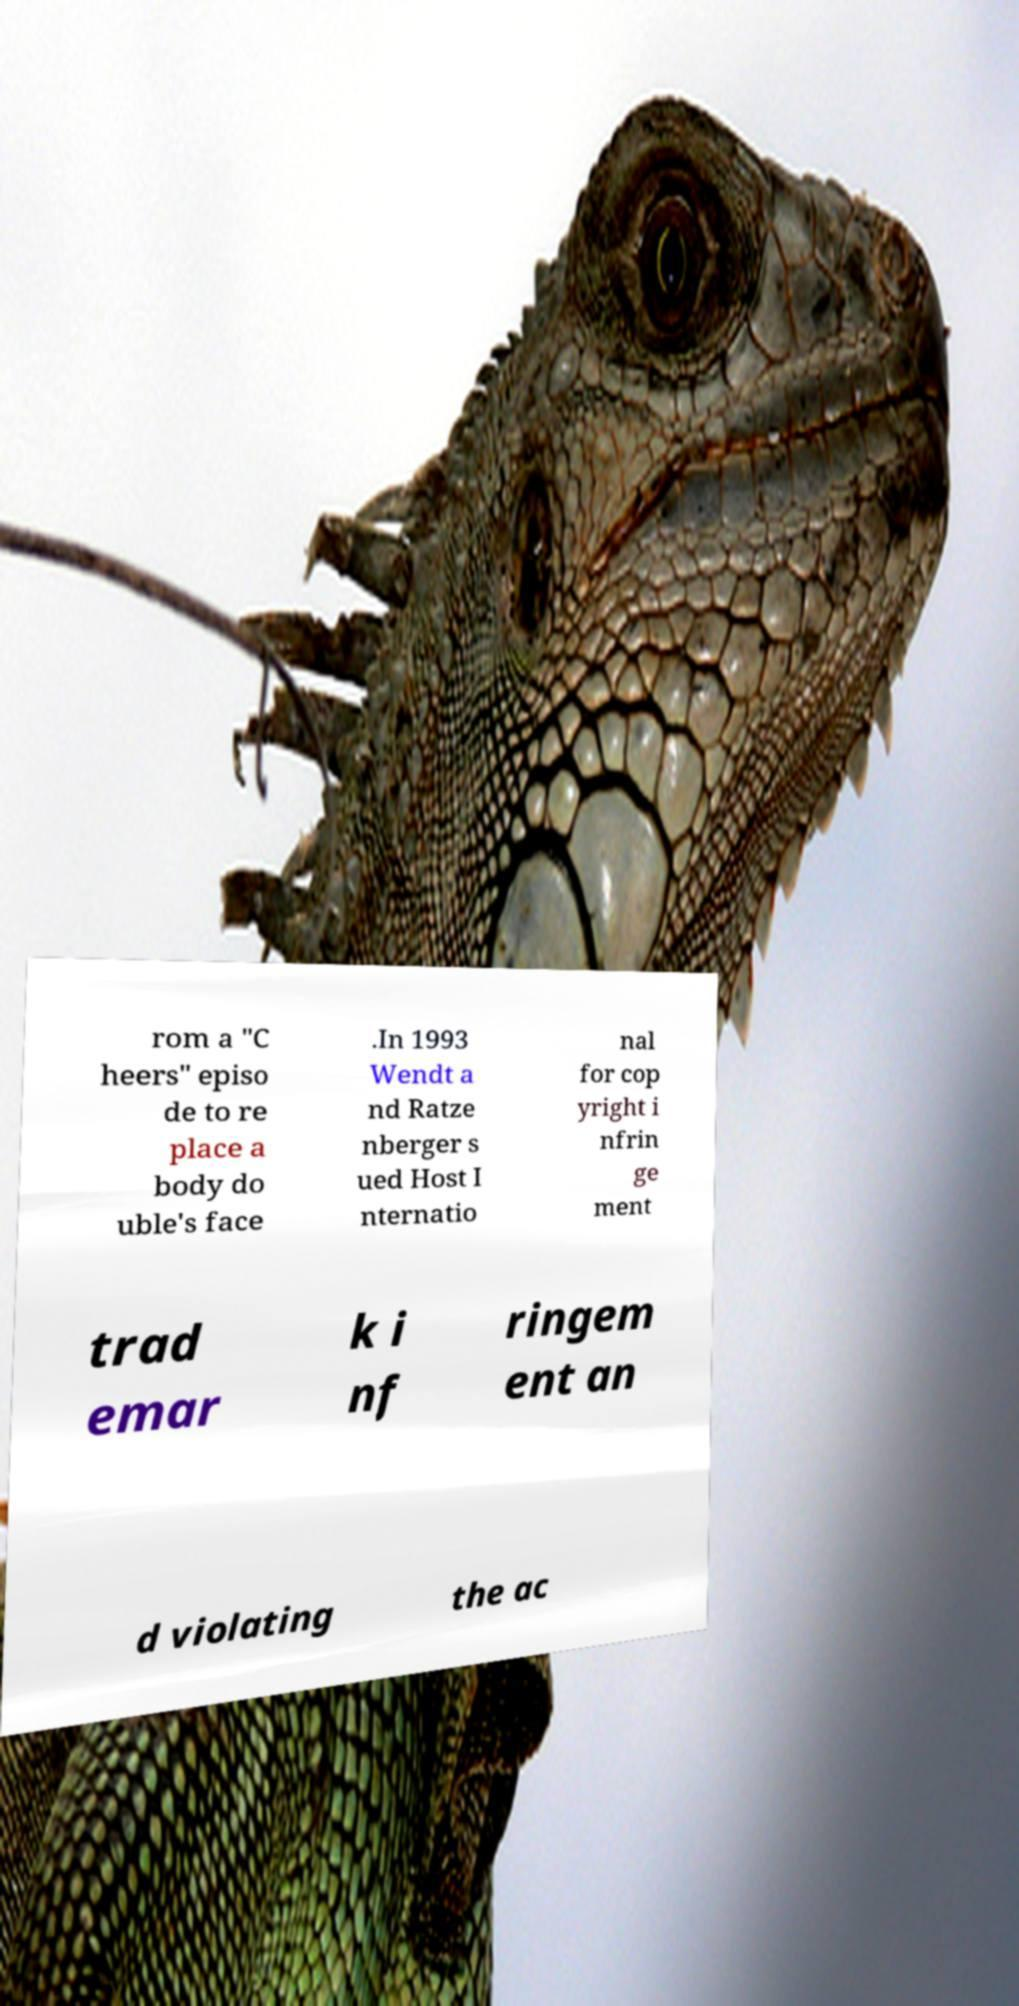I need the written content from this picture converted into text. Can you do that? rom a "C heers" episo de to re place a body do uble's face .In 1993 Wendt a nd Ratze nberger s ued Host I nternatio nal for cop yright i nfrin ge ment trad emar k i nf ringem ent an d violating the ac 